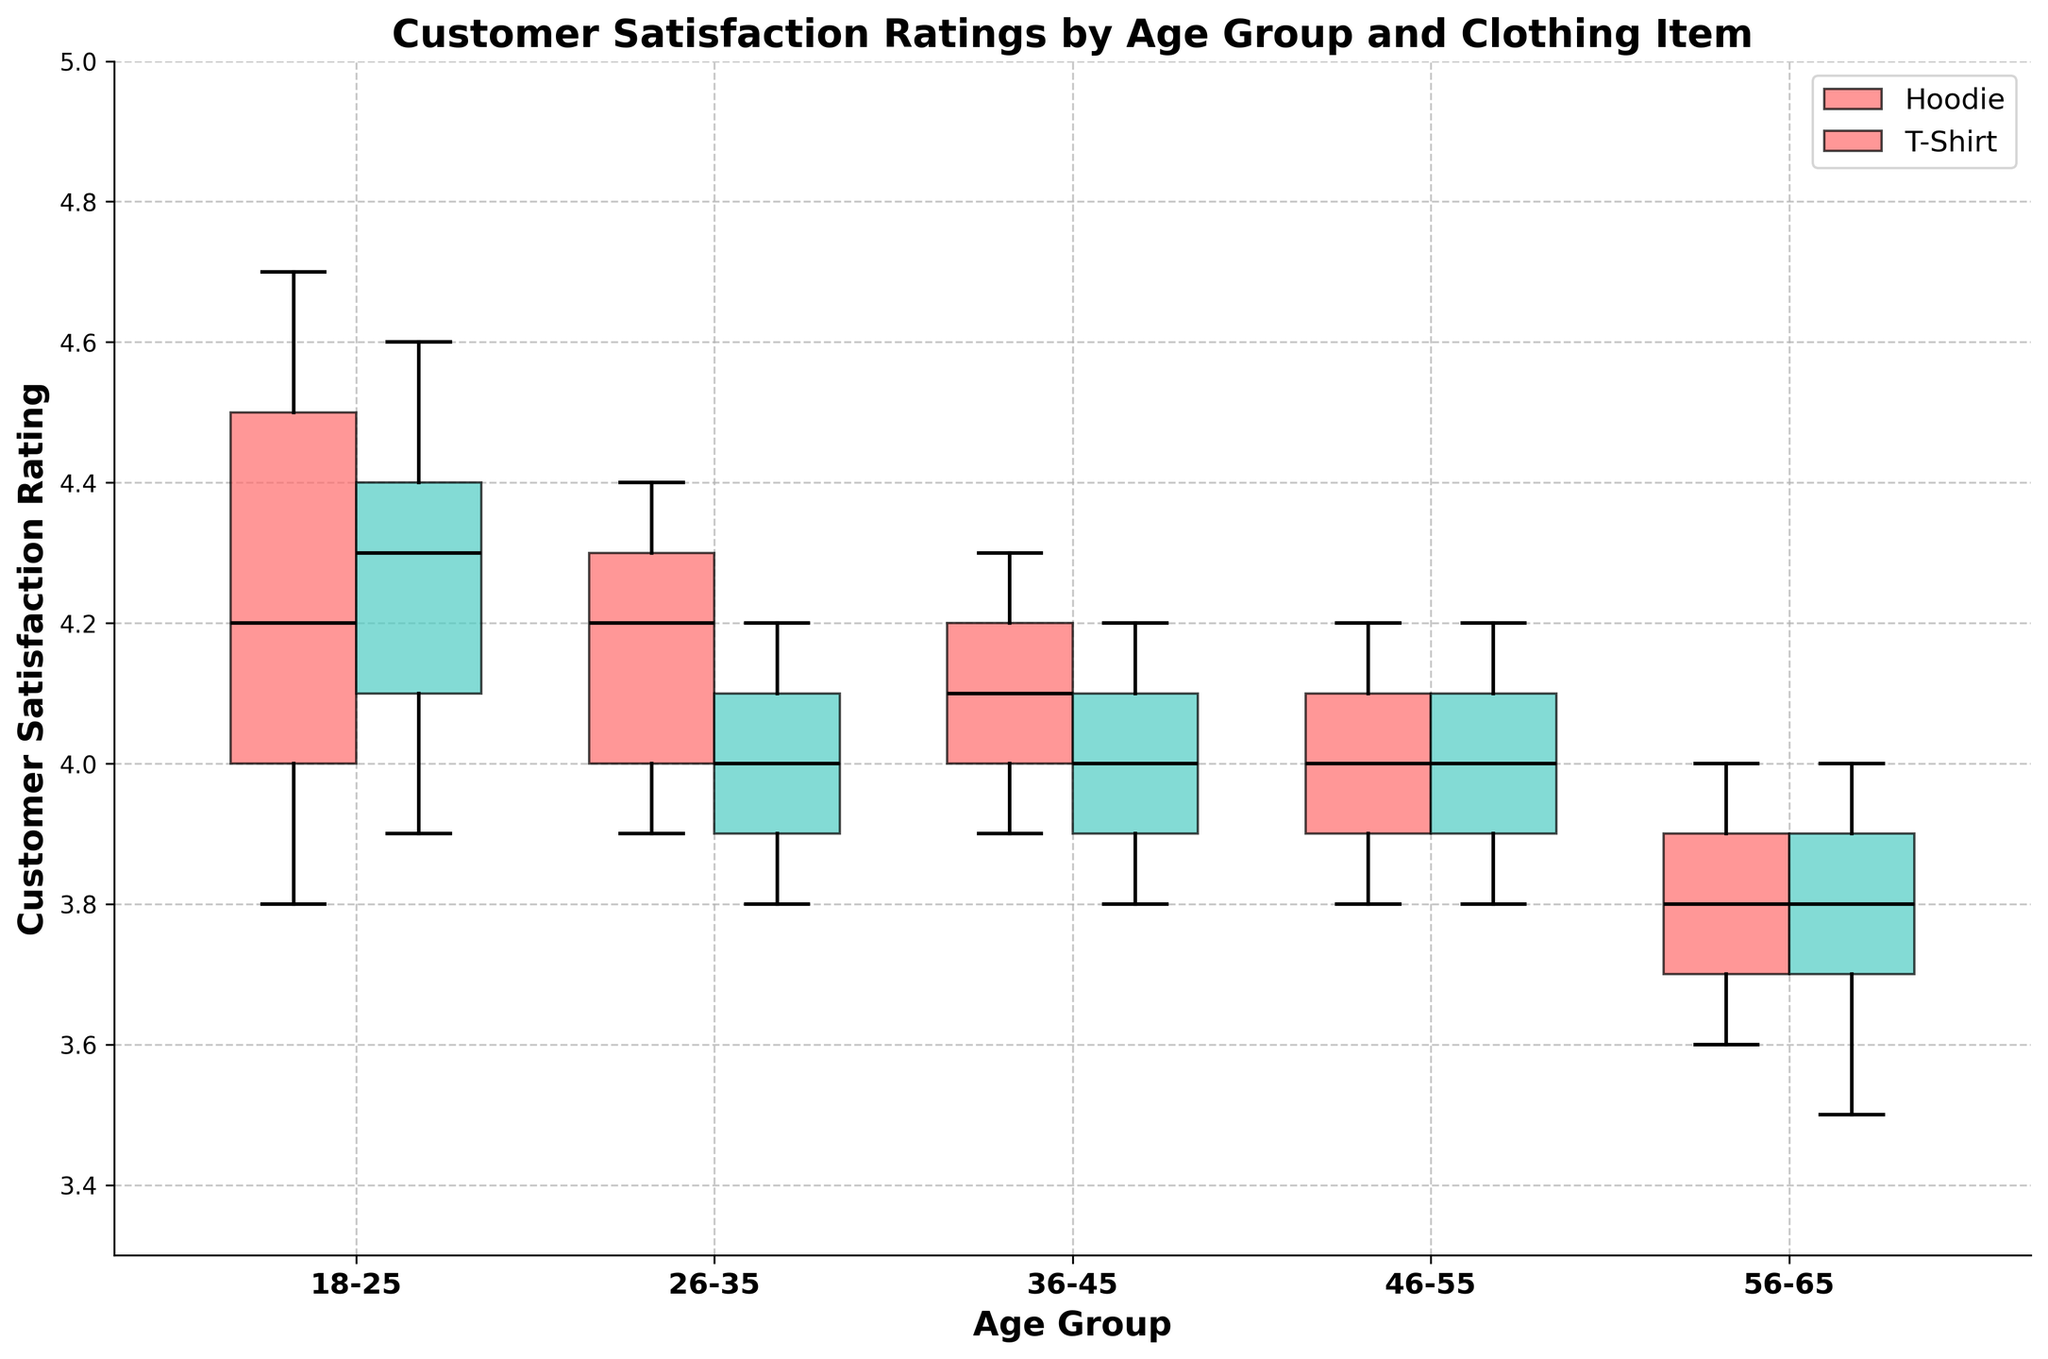What is the title of the plot? The title of the plot is located at the top and it indicates the main topic or variable of interest being analyzed in the plot. The title should be clear and descriptive.
Answer: Customer Satisfaction Ratings by Age Group and Clothing Item What are the age groups represented on the x-axis? The x-axis of the plot shows the categories of age groups, each of which is labeled and spans from left to right. These categories should be visible directly under the x-axis.
Answer: 18-25, 26-35, 36-45, 46-55, 56-65 Which clothing item appears to have the highest median satisfaction rating among the 18-25 age group? Observing the notches (middle line within the boxes) in the box plots for the 18-25 age group, identify the highest median value between the two clothing items: Hoodies and T-Shirts.
Answer: Hoodie What is the color of the box plot representing T-Shirts? The color of the box plot for T-Shirts is indicated by the legend typically located at the side or bottom of the plot. In this case, look for the color listed next to T-Shirt in the legend.
Answer: Teal How does the variability in satisfaction ratings for Hoodies compare between the 46-55 and 56-65 age groups? To assess variability, examine the width of the interquartile range (IQR), which is the width of the box plot. A wider box indicates more variability. Compare the box widths between the two specified age groups.
Answer: 46-55 has slightly less variability than 56-65 What age group has the smallest interquartile range for T-Shirts? The interquartile range (IQR) is represented by the height of the box in the box plot. The age group with the smallest box for T-Shirts indicates the lowest variability.
Answer: 26-35 Which age group shows more variability in satisfaction ratings for Hoodies? Measure the length of the box (IQR) and the whiskers (range) for Hoodies across all age groups. Identify the age group with the longest combined length.
Answer: 56-65 What does a notched box plot indicate about the median customer satisfaction ratings between age groups and clothing items? Notched box plots allow you to compare medians and visualize the confidence intervals of these medians. If the notches of two box plots do not overlap, it suggests a statistically significant difference between the medians. Assess if there are overlaps between any box plots for different age groups and items.
Answer: Overlaps indicate no significant difference What is the range of customer satisfaction ratings for Hoodies in the 36-45 age group? The range is determined by the distance between the smallest and largest values indicated by the whiskers of the box plot.
Answer: 3.9 to 4.3 Which clothing item has higher overall customer satisfaction ratings across all age groups? To determine this, visually compare the median (horizontal line within each box) of each clothing item across all age groups and determine which consistently has higher medians.
Answer: Hoodie 